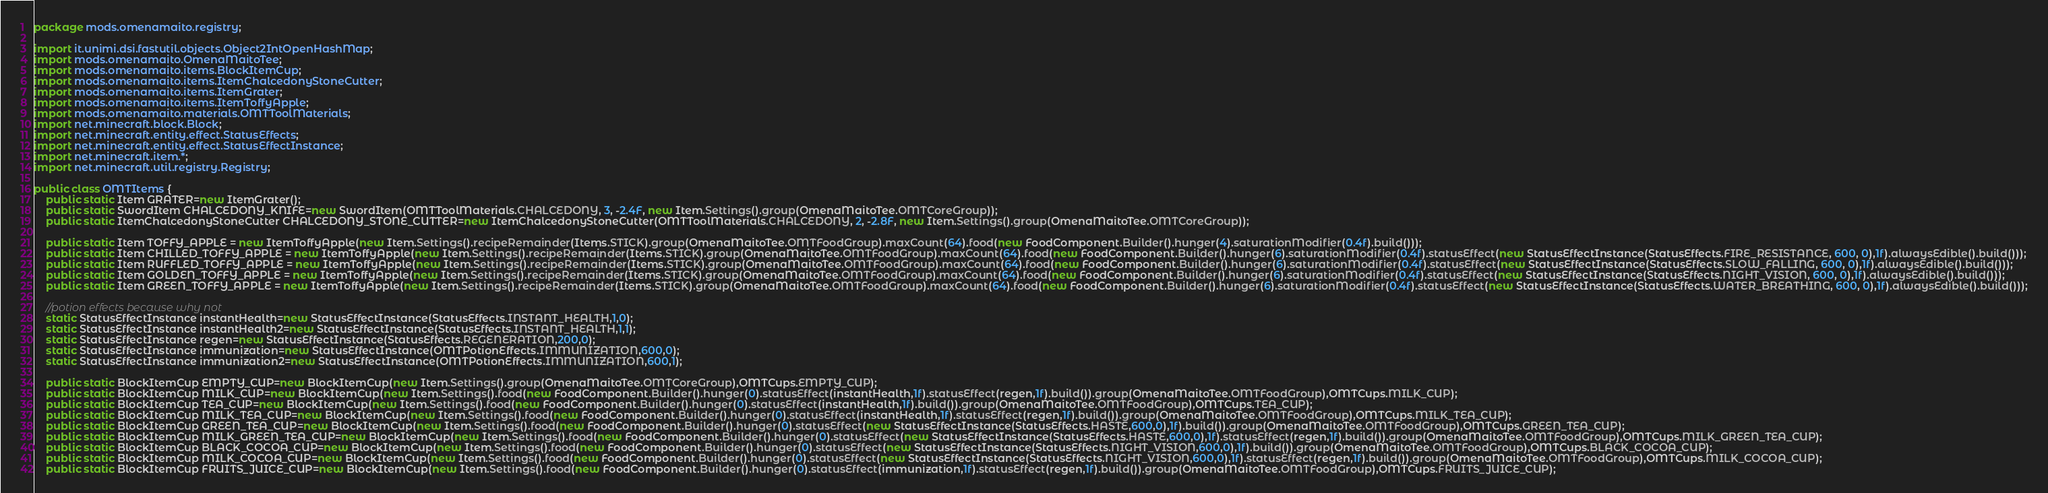<code> <loc_0><loc_0><loc_500><loc_500><_Java_>package mods.omenamaito.registry;

import it.unimi.dsi.fastutil.objects.Object2IntOpenHashMap;
import mods.omenamaito.OmenaMaitoTee;
import mods.omenamaito.items.BlockItemCup;
import mods.omenamaito.items.ItemChalcedonyStoneCutter;
import mods.omenamaito.items.ItemGrater;
import mods.omenamaito.items.ItemToffyApple;
import mods.omenamaito.materials.OMTToolMaterials;
import net.minecraft.block.Block;
import net.minecraft.entity.effect.StatusEffects;
import net.minecraft.entity.effect.StatusEffectInstance;
import net.minecraft.item.*;
import net.minecraft.util.registry.Registry;

public class OMTItems {
	public static Item GRATER=new ItemGrater();
	public static SwordItem CHALCEDONY_KNIFE=new SwordItem(OMTToolMaterials.CHALCEDONY, 3, -2.4F, new Item.Settings().group(OmenaMaitoTee.OMTCoreGroup));
	public static ItemChalcedonyStoneCutter CHALCEDONY_STONE_CUTTER=new ItemChalcedonyStoneCutter(OMTToolMaterials.CHALCEDONY, 2, -2.8F, new Item.Settings().group(OmenaMaitoTee.OMTCoreGroup));

	public static Item TOFFY_APPLE = new ItemToffyApple(new Item.Settings().recipeRemainder(Items.STICK).group(OmenaMaitoTee.OMTFoodGroup).maxCount(64).food(new FoodComponent.Builder().hunger(4).saturationModifier(0.4f).build()));
	public static Item CHILLED_TOFFY_APPLE = new ItemToffyApple(new Item.Settings().recipeRemainder(Items.STICK).group(OmenaMaitoTee.OMTFoodGroup).maxCount(64).food(new FoodComponent.Builder().hunger(6).saturationModifier(0.4f).statusEffect(new StatusEffectInstance(StatusEffects.FIRE_RESISTANCE, 600, 0),1f).alwaysEdible().build()));
	public static Item RUFFLED_TOFFY_APPLE = new ItemToffyApple(new Item.Settings().recipeRemainder(Items.STICK).group(OmenaMaitoTee.OMTFoodGroup).maxCount(64).food(new FoodComponent.Builder().hunger(6).saturationModifier(0.4f).statusEffect(new StatusEffectInstance(StatusEffects.SLOW_FALLING, 600, 0),1f).alwaysEdible().build()));
	public static Item GOLDEN_TOFFY_APPLE = new ItemToffyApple(new Item.Settings().recipeRemainder(Items.STICK).group(OmenaMaitoTee.OMTFoodGroup).maxCount(64).food(new FoodComponent.Builder().hunger(6).saturationModifier(0.4f).statusEffect(new StatusEffectInstance(StatusEffects.NIGHT_VISION, 600, 0),1f).alwaysEdible().build()));
	public static Item GREEN_TOFFY_APPLE = new ItemToffyApple(new Item.Settings().recipeRemainder(Items.STICK).group(OmenaMaitoTee.OMTFoodGroup).maxCount(64).food(new FoodComponent.Builder().hunger(6).saturationModifier(0.4f).statusEffect(new StatusEffectInstance(StatusEffects.WATER_BREATHING, 600, 0),1f).alwaysEdible().build()));

	//potion effects because why not
	static StatusEffectInstance instantHealth=new StatusEffectInstance(StatusEffects.INSTANT_HEALTH,1,0);
	static StatusEffectInstance instantHealth2=new StatusEffectInstance(StatusEffects.INSTANT_HEALTH,1,1);
	static StatusEffectInstance regen=new StatusEffectInstance(StatusEffects.REGENERATION,200,0);
	static StatusEffectInstance immunization=new StatusEffectInstance(OMTPotionEffects.IMMUNIZATION,600,0);
	static StatusEffectInstance immunization2=new StatusEffectInstance(OMTPotionEffects.IMMUNIZATION,600,1);

	public static BlockItemCup EMPTY_CUP=new BlockItemCup(new Item.Settings().group(OmenaMaitoTee.OMTCoreGroup),OMTCups.EMPTY_CUP);
	public static BlockItemCup MILK_CUP=new BlockItemCup(new Item.Settings().food(new FoodComponent.Builder().hunger(0).statusEffect(instantHealth,1f).statusEffect(regen,1f).build()).group(OmenaMaitoTee.OMTFoodGroup),OMTCups.MILK_CUP);
	public static BlockItemCup TEA_CUP=new BlockItemCup(new Item.Settings().food(new FoodComponent.Builder().hunger(0).statusEffect(instantHealth,1f).build()).group(OmenaMaitoTee.OMTFoodGroup),OMTCups.TEA_CUP);
	public static BlockItemCup MILK_TEA_CUP=new BlockItemCup(new Item.Settings().food(new FoodComponent.Builder().hunger(0).statusEffect(instantHealth,1f).statusEffect(regen,1f).build()).group(OmenaMaitoTee.OMTFoodGroup),OMTCups.MILK_TEA_CUP);
	public static BlockItemCup GREEN_TEA_CUP=new BlockItemCup(new Item.Settings().food(new FoodComponent.Builder().hunger(0).statusEffect(new StatusEffectInstance(StatusEffects.HASTE,600,0),1f).build()).group(OmenaMaitoTee.OMTFoodGroup),OMTCups.GREEN_TEA_CUP);
	public static BlockItemCup MILK_GREEN_TEA_CUP=new BlockItemCup(new Item.Settings().food(new FoodComponent.Builder().hunger(0).statusEffect(new StatusEffectInstance(StatusEffects.HASTE,600,0),1f).statusEffect(regen,1f).build()).group(OmenaMaitoTee.OMTFoodGroup),OMTCups.MILK_GREEN_TEA_CUP);
	public static BlockItemCup BLACK_COCOA_CUP=new BlockItemCup(new Item.Settings().food(new FoodComponent.Builder().hunger(0).statusEffect(new StatusEffectInstance(StatusEffects.NIGHT_VISION,600,0),1f).build()).group(OmenaMaitoTee.OMTFoodGroup),OMTCups.BLACK_COCOA_CUP);
	public static BlockItemCup MILK_COCOA_CUP=new BlockItemCup(new Item.Settings().food(new FoodComponent.Builder().hunger(0).statusEffect(new StatusEffectInstance(StatusEffects.NIGHT_VISION,600,0),1f).statusEffect(regen,1f).build()).group(OmenaMaitoTee.OMTFoodGroup),OMTCups.MILK_COCOA_CUP);
	public static BlockItemCup FRUITS_JUICE_CUP=new BlockItemCup(new Item.Settings().food(new FoodComponent.Builder().hunger(0).statusEffect(immunization,1f).statusEffect(regen,1f).build()).group(OmenaMaitoTee.OMTFoodGroup),OMTCups.FRUITS_JUICE_CUP);</code> 